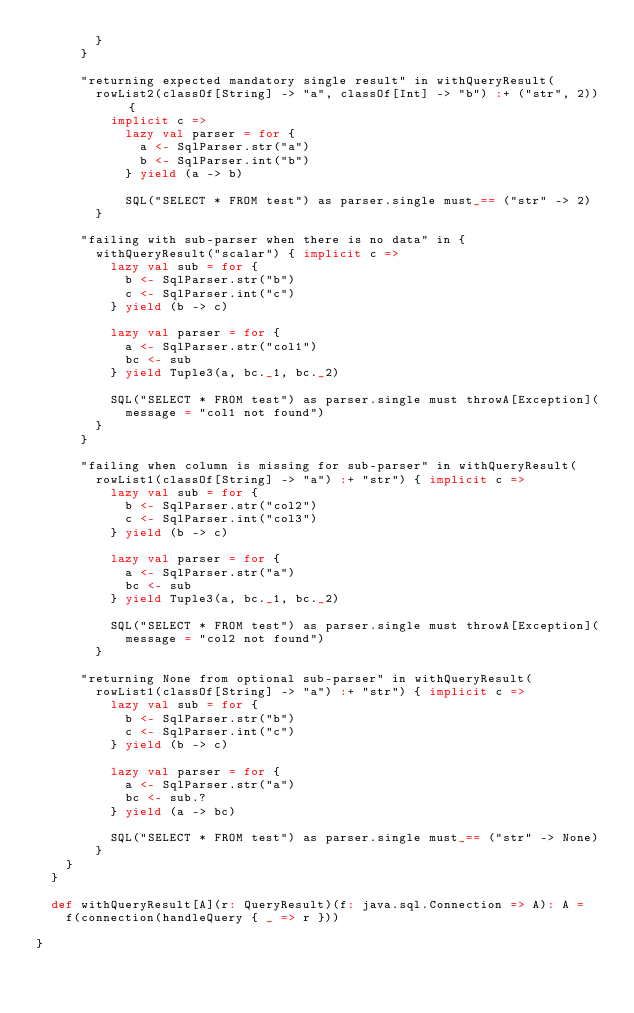<code> <loc_0><loc_0><loc_500><loc_500><_Scala_>        }
      }

      "returning expected mandatory single result" in withQueryResult(
        rowList2(classOf[String] -> "a", classOf[Int] -> "b") :+ ("str", 2)) {
          implicit c =>
            lazy val parser = for {
              a <- SqlParser.str("a")
              b <- SqlParser.int("b")
            } yield (a -> b)

            SQL("SELECT * FROM test") as parser.single must_== ("str" -> 2)
        }

      "failing with sub-parser when there is no data" in {
        withQueryResult("scalar") { implicit c =>
          lazy val sub = for {
            b <- SqlParser.str("b")
            c <- SqlParser.int("c")
          } yield (b -> c)

          lazy val parser = for {
            a <- SqlParser.str("col1")
            bc <- sub
          } yield Tuple3(a, bc._1, bc._2)

          SQL("SELECT * FROM test") as parser.single must throwA[Exception](
            message = "col1 not found")
        }
      }

      "failing when column is missing for sub-parser" in withQueryResult(
        rowList1(classOf[String] -> "a") :+ "str") { implicit c =>
          lazy val sub = for {
            b <- SqlParser.str("col2")
            c <- SqlParser.int("col3")
          } yield (b -> c)

          lazy val parser = for {
            a <- SqlParser.str("a")
            bc <- sub
          } yield Tuple3(a, bc._1, bc._2)

          SQL("SELECT * FROM test") as parser.single must throwA[Exception](
            message = "col2 not found")
        }

      "returning None from optional sub-parser" in withQueryResult(
        rowList1(classOf[String] -> "a") :+ "str") { implicit c =>
          lazy val sub = for {
            b <- SqlParser.str("b")
            c <- SqlParser.int("c")
          } yield (b -> c)

          lazy val parser = for {
            a <- SqlParser.str("a")
            bc <- sub.?
          } yield (a -> bc)

          SQL("SELECT * FROM test") as parser.single must_== ("str" -> None)
        }
    }
  }

  def withQueryResult[A](r: QueryResult)(f: java.sql.Connection => A): A =
    f(connection(handleQuery { _ => r }))

}
</code> 